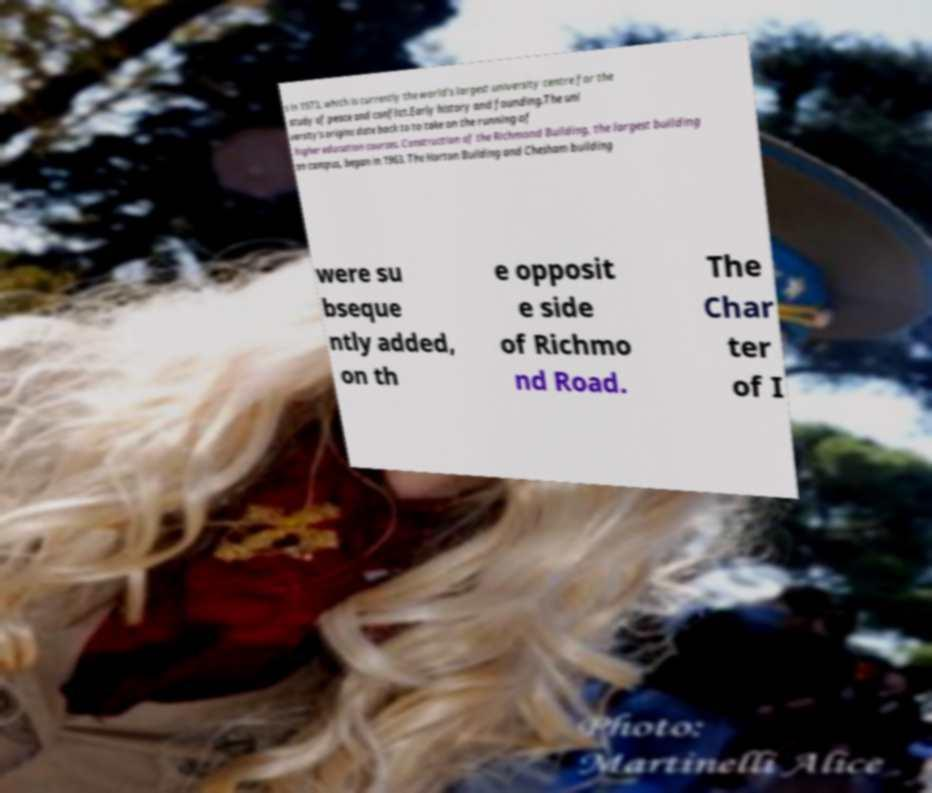For documentation purposes, I need the text within this image transcribed. Could you provide that? s in 1973, which is currently the world's largest university centre for the study of peace and conflict.Early history and founding.The uni versity's origins date back to to take on the running of higher education courses. Construction of the Richmond Building, the largest building on campus, began in 1963. The Horton Building and Chesham building were su bseque ntly added, on th e opposit e side of Richmo nd Road. The Char ter of I 